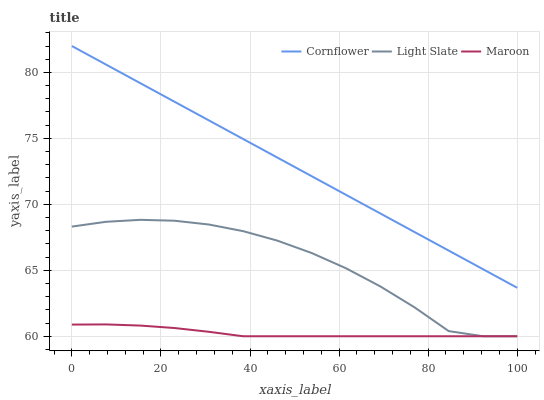Does Maroon have the minimum area under the curve?
Answer yes or no. Yes. Does Cornflower have the maximum area under the curve?
Answer yes or no. Yes. Does Cornflower have the minimum area under the curve?
Answer yes or no. No. Does Maroon have the maximum area under the curve?
Answer yes or no. No. Is Cornflower the smoothest?
Answer yes or no. Yes. Is Light Slate the roughest?
Answer yes or no. Yes. Is Maroon the smoothest?
Answer yes or no. No. Is Maroon the roughest?
Answer yes or no. No. Does Light Slate have the lowest value?
Answer yes or no. Yes. Does Cornflower have the lowest value?
Answer yes or no. No. Does Cornflower have the highest value?
Answer yes or no. Yes. Does Maroon have the highest value?
Answer yes or no. No. Is Light Slate less than Cornflower?
Answer yes or no. Yes. Is Cornflower greater than Light Slate?
Answer yes or no. Yes. Does Maroon intersect Light Slate?
Answer yes or no. Yes. Is Maroon less than Light Slate?
Answer yes or no. No. Is Maroon greater than Light Slate?
Answer yes or no. No. Does Light Slate intersect Cornflower?
Answer yes or no. No. 